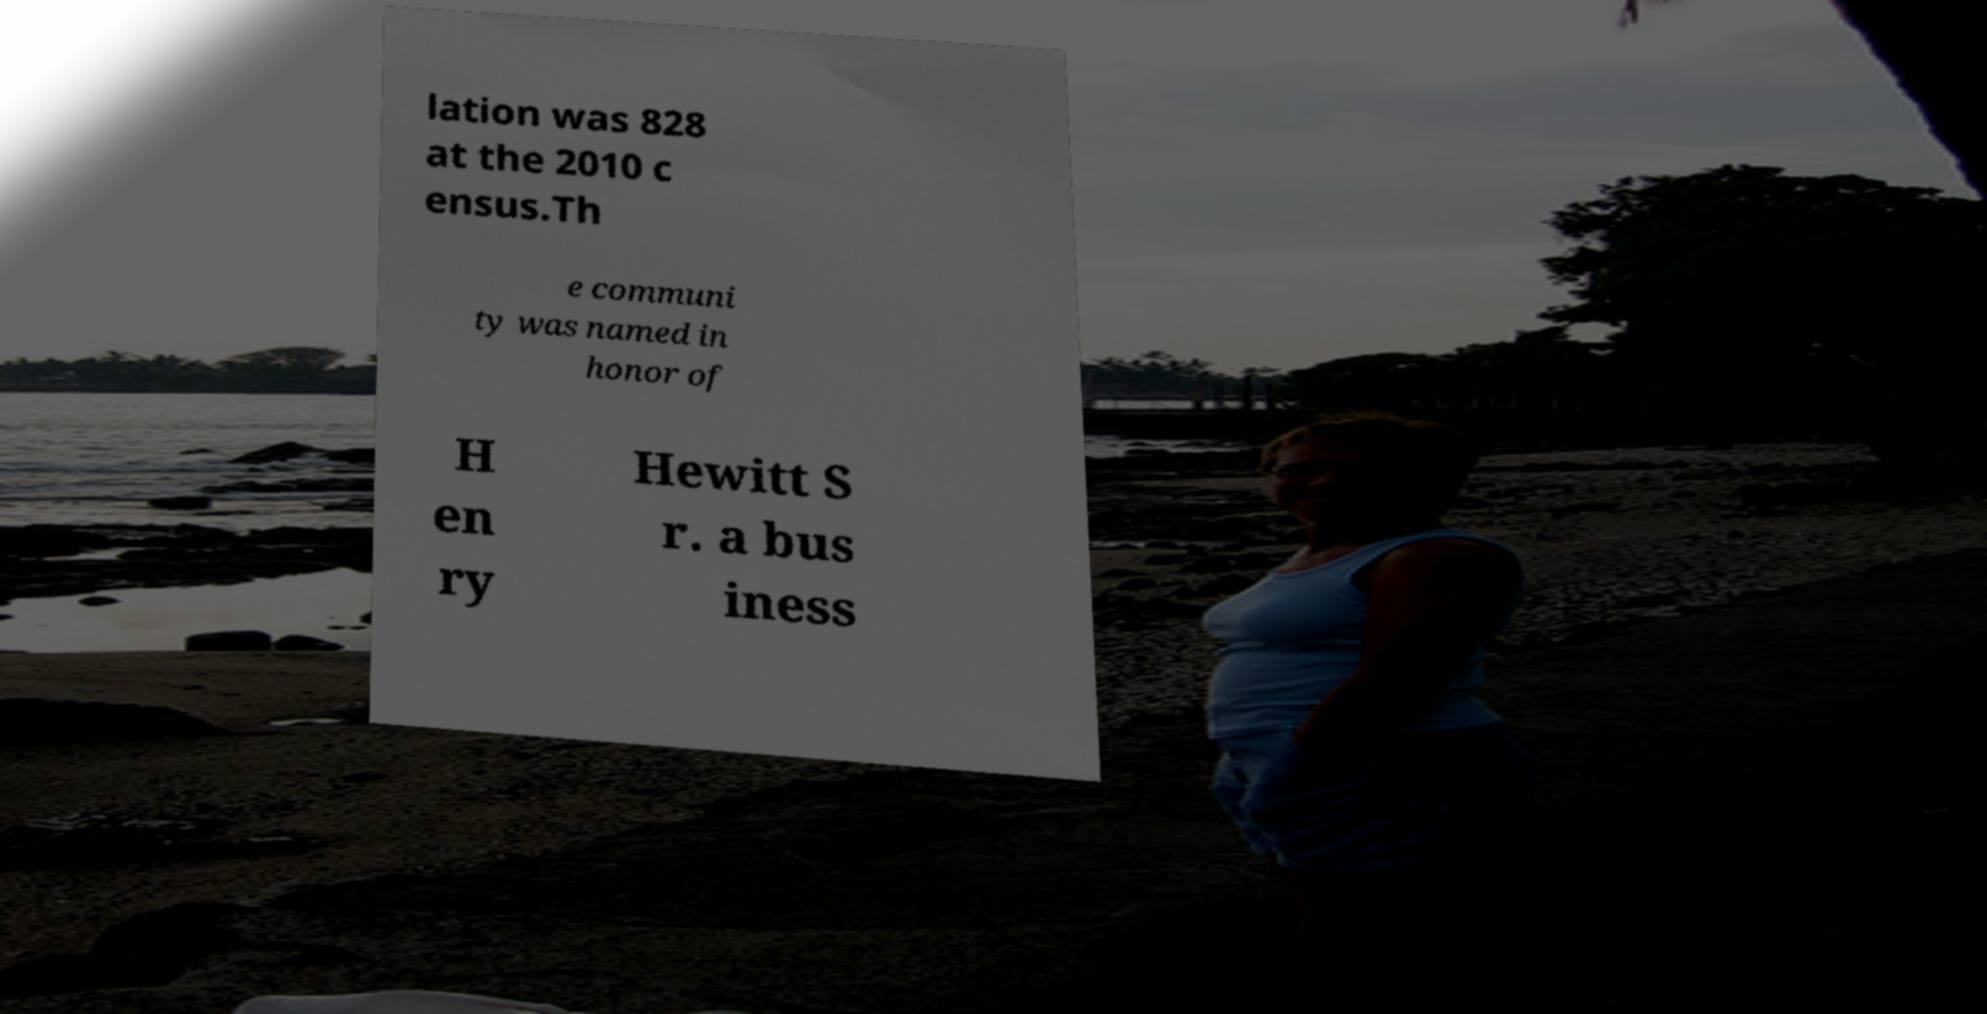What messages or text are displayed in this image? I need them in a readable, typed format. lation was 828 at the 2010 c ensus.Th e communi ty was named in honor of H en ry Hewitt S r. a bus iness 